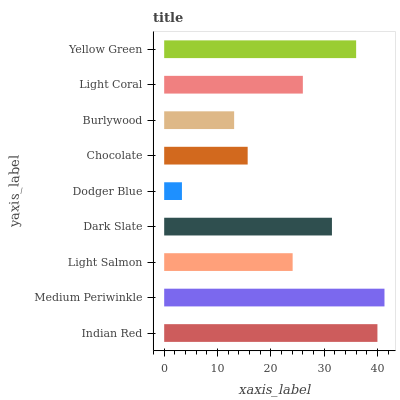Is Dodger Blue the minimum?
Answer yes or no. Yes. Is Medium Periwinkle the maximum?
Answer yes or no. Yes. Is Light Salmon the minimum?
Answer yes or no. No. Is Light Salmon the maximum?
Answer yes or no. No. Is Medium Periwinkle greater than Light Salmon?
Answer yes or no. Yes. Is Light Salmon less than Medium Periwinkle?
Answer yes or no. Yes. Is Light Salmon greater than Medium Periwinkle?
Answer yes or no. No. Is Medium Periwinkle less than Light Salmon?
Answer yes or no. No. Is Light Coral the high median?
Answer yes or no. Yes. Is Light Coral the low median?
Answer yes or no. Yes. Is Chocolate the high median?
Answer yes or no. No. Is Light Salmon the low median?
Answer yes or no. No. 